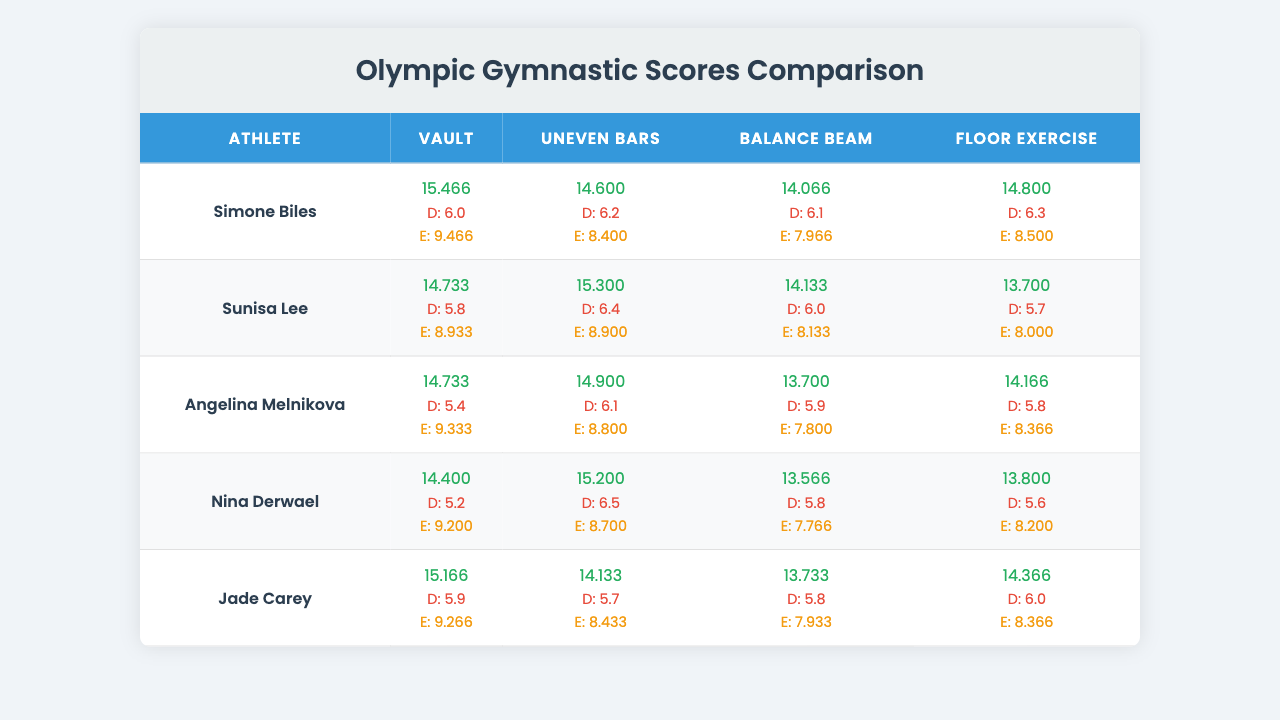What is Simone Biles' highest score among all apparatus? By looking at the scores for Simone Biles, we can see that the highest value is 15.466 in the Vault category.
Answer: 15.466 Which athlete scored the lowest on the Balance Beam? Checking the Balance Beam scores, Nina Derwael has the lowest score of 13.566.
Answer: 13.566 What is the average score for Jade Carey across all apparatus? To find the average score for Jade Carey, we sum her scores: (15.166 + 14.133 + 13.733 + 14.366) = 57.398. Then, we divide by 4 to get the average: 57.398 / 4 = 14.3495.
Answer: 14.3495 Did any athlete receive a difficulty rating of 6.0 on the Balance Beam? Reviewing the Balance Beam difficulty ratings, it can be observed that no athlete has a difficulty rating of exactly 6.0.
Answer: No Which athlete had the highest execution score on the Floor Exercise? Looking at the Floor Exercise execution scores, we see that Simone Biles received the highest execution score of 8.500.
Answer: 8.500 What is the difference between Sunisa Lee's Vault score and her Floor Exercise score? Sunisa Lee's Vault score is 14.733, and her Floor Exercise score is 13.700. Calculating the difference: 14.733 - 13.700 = 1.033.
Answer: 1.033 How do the average scores of the athletes compare across all apparatus? First, we calculate the total scores for each athlete and then divide by 4. The scores are: Simone Biles (14.983), Sunisa Lee (12.978), Angelina Melnikova (12.775), Nina Derwael (12.791), Jade Carey (14.599). The highest average is for Simone Biles and the lowest is for Angelina Melnikova.
Answer: Highest: Simone Biles, Lowest: Angelina Melnikova What is the overall average difficulty rating across all athletes and apparatus? To find the overall average difficulty, sum all difficulty ratings (6.0 + 6.2 + 6.1 + 6.3 + 5.8 + 6.4 + 6.0 + 5.7 + 5.4 + 6.1 + 5.9 + 5.8 + 5.2 + 6.5 + 5.8 + 5.6 + 5.9 + 5.7 + 5.8 + 6.0) = 116.5. Then, divide by the total number of scores (20): 116.5 / 20 = 5.825.
Answer: 5.825 Which athlete consistently performed better on the Uneven Bars compared to others? Reviewing the scores, Sunisa Lee has the highest score of 15.300 on the Uneven Bars, compared to others' scores in this apparatus.
Answer: Sunisa Lee Is the execution score for Jade Carey lower than the execution score for Simone Biles on any of the apparatus? Checking the execution scores reveals that Jade Carey's execution score is lower than Simone Biles only on the Balance Beam (Jade: 7.933, Simone: 7.966).
Answer: Yes 